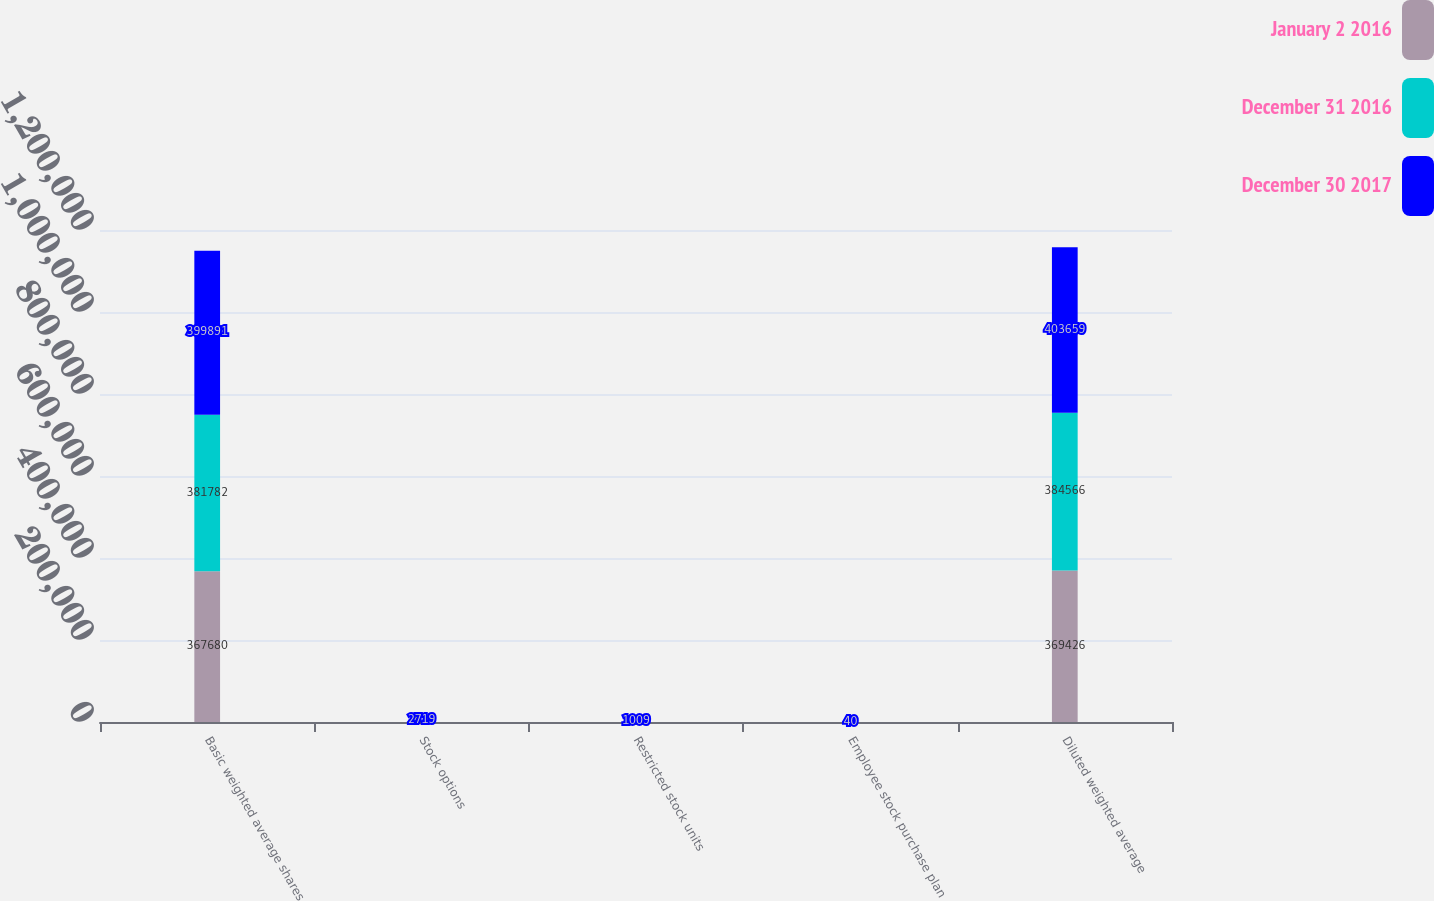Convert chart to OTSL. <chart><loc_0><loc_0><loc_500><loc_500><stacked_bar_chart><ecel><fcel>Basic weighted average shares<fcel>Stock options<fcel>Restricted stock units<fcel>Employee stock purchase plan<fcel>Diluted weighted average<nl><fcel>January 2 2016<fcel>367680<fcel>1435<fcel>307<fcel>4<fcel>369426<nl><fcel>December 31 2016<fcel>381782<fcel>1983<fcel>756<fcel>45<fcel>384566<nl><fcel>December 30 2017<fcel>399891<fcel>2719<fcel>1009<fcel>40<fcel>403659<nl></chart> 